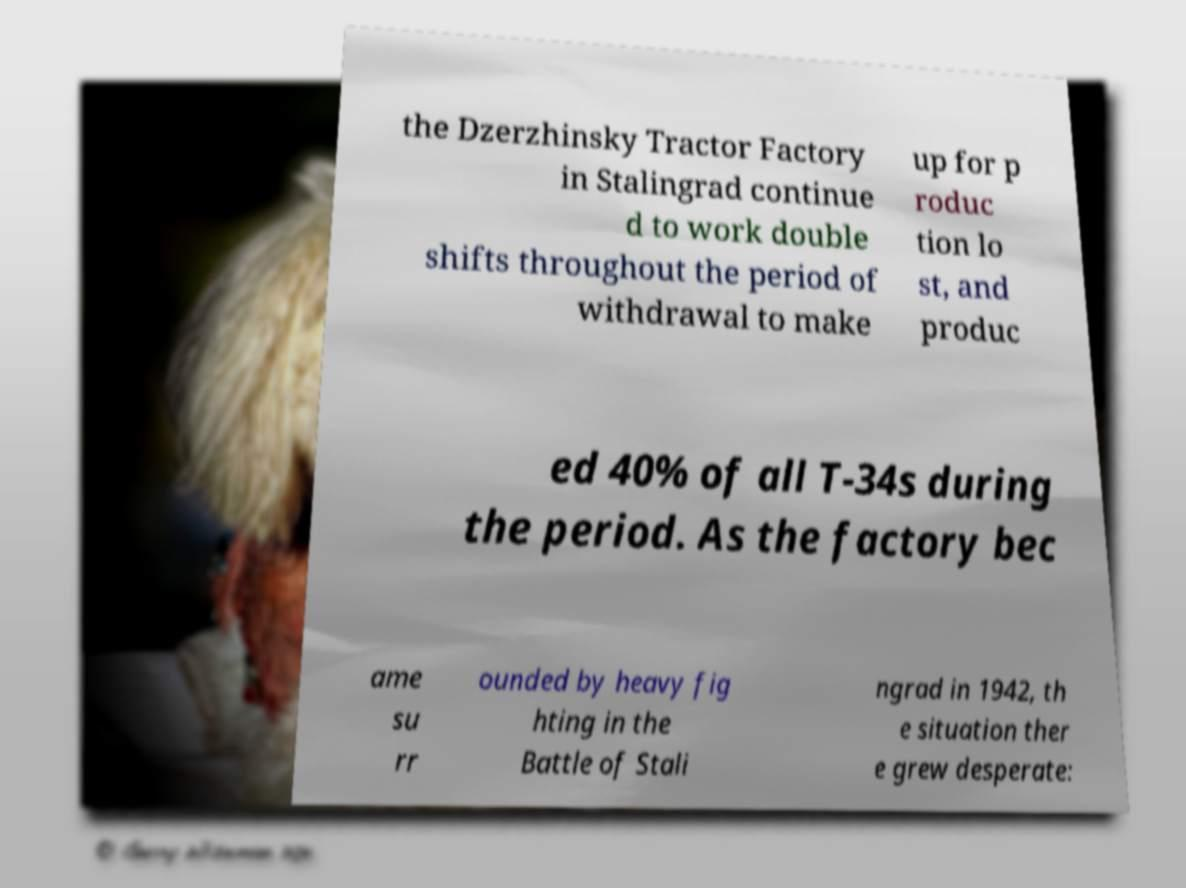Could you assist in decoding the text presented in this image and type it out clearly? the Dzerzhinsky Tractor Factory in Stalingrad continue d to work double shifts throughout the period of withdrawal to make up for p roduc tion lo st, and produc ed 40% of all T-34s during the period. As the factory bec ame su rr ounded by heavy fig hting in the Battle of Stali ngrad in 1942, th e situation ther e grew desperate: 